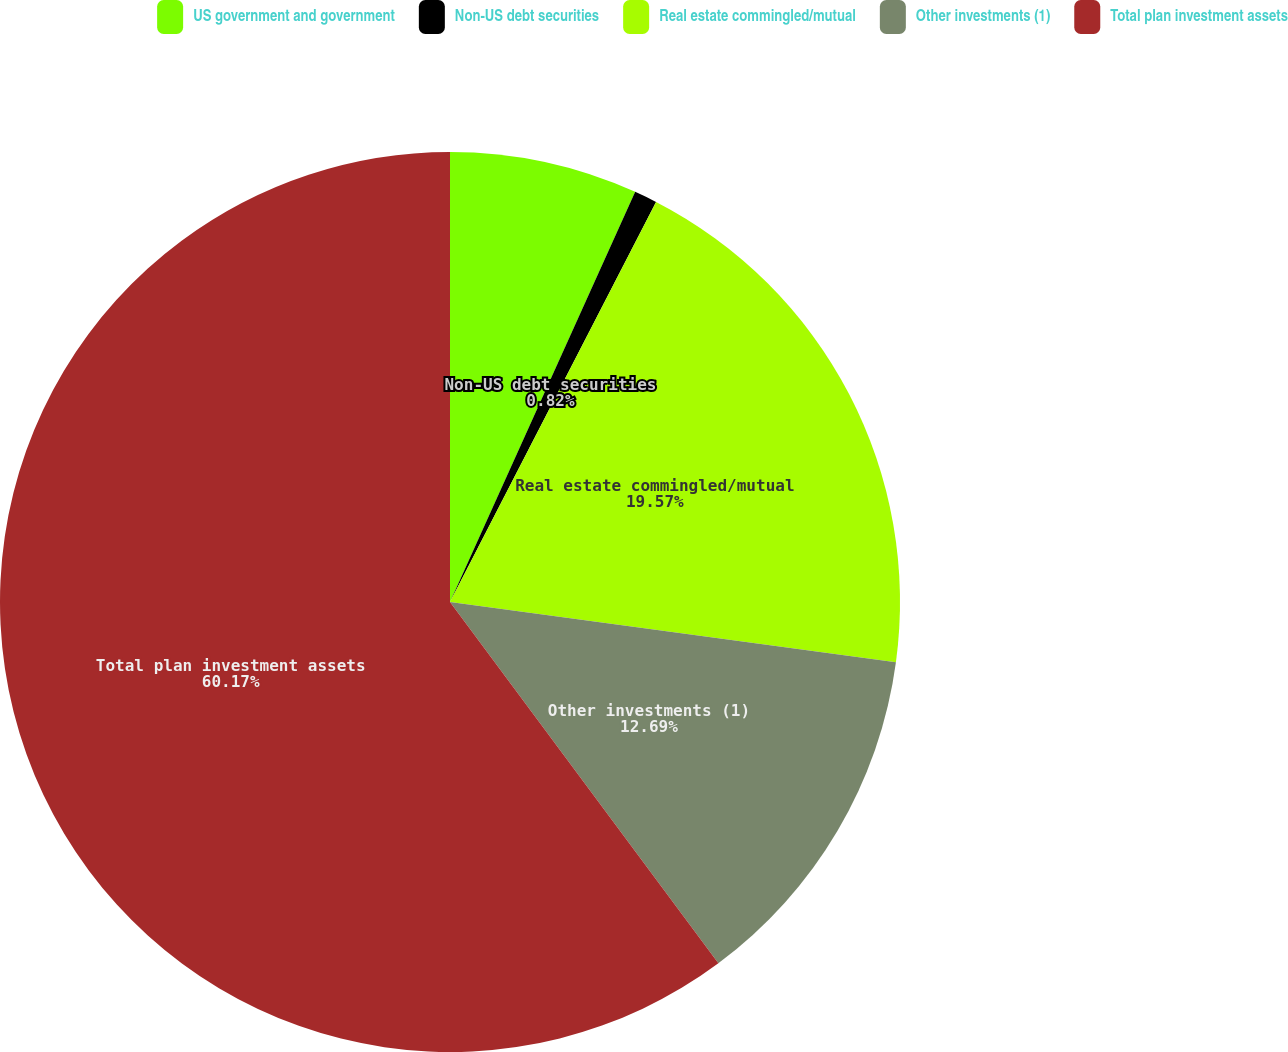<chart> <loc_0><loc_0><loc_500><loc_500><pie_chart><fcel>US government and government<fcel>Non-US debt securities<fcel>Real estate commingled/mutual<fcel>Other investments (1)<fcel>Total plan investment assets<nl><fcel>6.75%<fcel>0.82%<fcel>19.57%<fcel>12.69%<fcel>60.17%<nl></chart> 